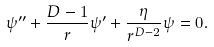Convert formula to latex. <formula><loc_0><loc_0><loc_500><loc_500>\psi ^ { \prime \prime } + \frac { D - 1 } { r } \psi ^ { \prime } + \frac { \eta } { r ^ { D - 2 } } \psi = 0 .</formula> 